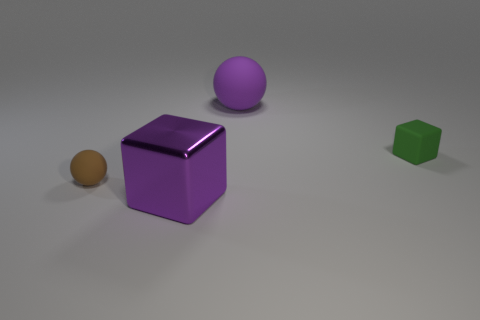Which of the objects is closest to the foreground? The brown ball appears to be the object closest to the foreground of the image. 